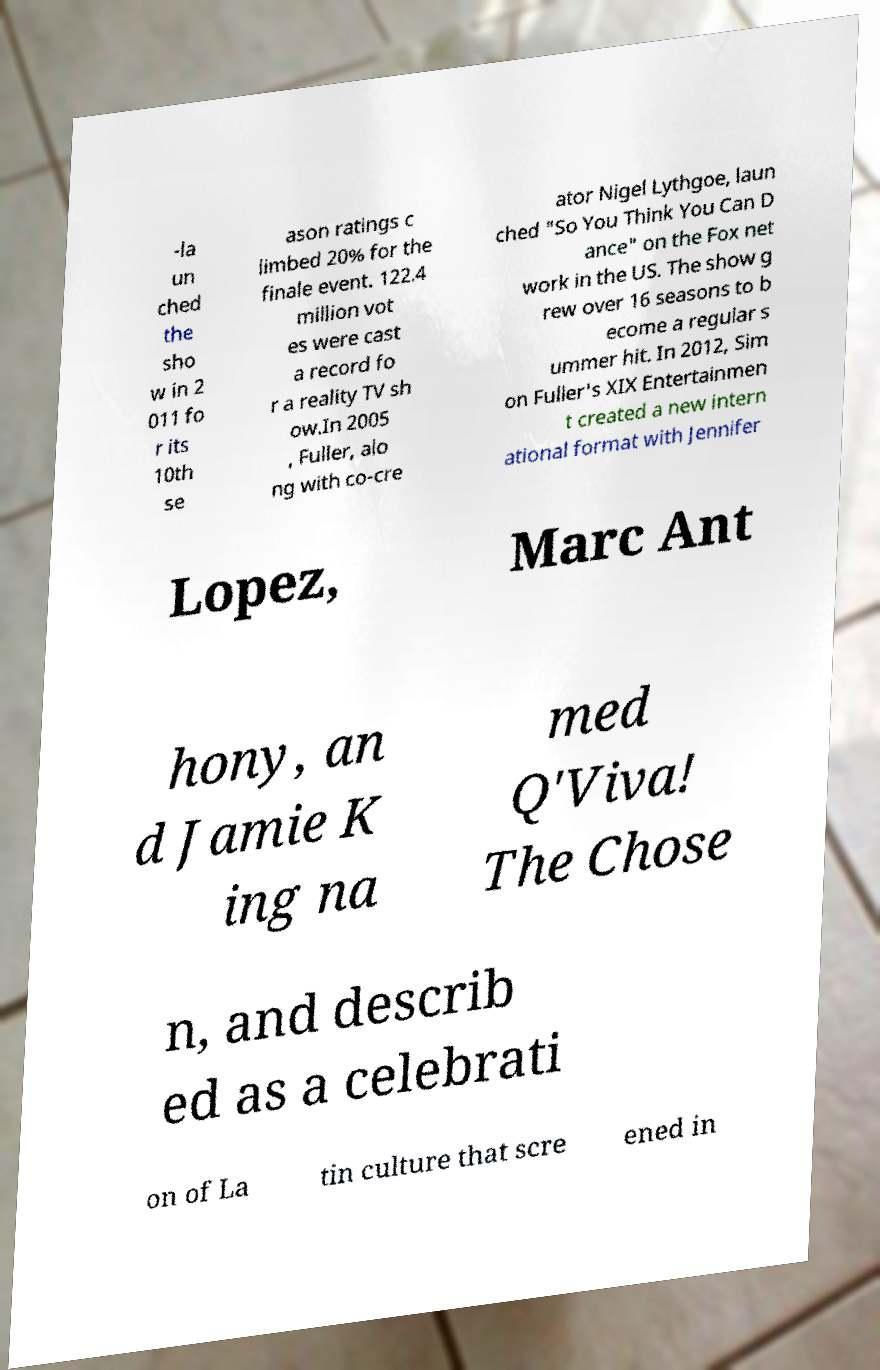I need the written content from this picture converted into text. Can you do that? -la un ched the sho w in 2 011 fo r its 10th se ason ratings c limbed 20% for the finale event. 122.4 million vot es were cast a record fo r a reality TV sh ow.In 2005 , Fuller, alo ng with co-cre ator Nigel Lythgoe, laun ched "So You Think You Can D ance" on the Fox net work in the US. The show g rew over 16 seasons to b ecome a regular s ummer hit. In 2012, Sim on Fuller's XIX Entertainmen t created a new intern ational format with Jennifer Lopez, Marc Ant hony, an d Jamie K ing na med Q'Viva! The Chose n, and describ ed as a celebrati on of La tin culture that scre ened in 